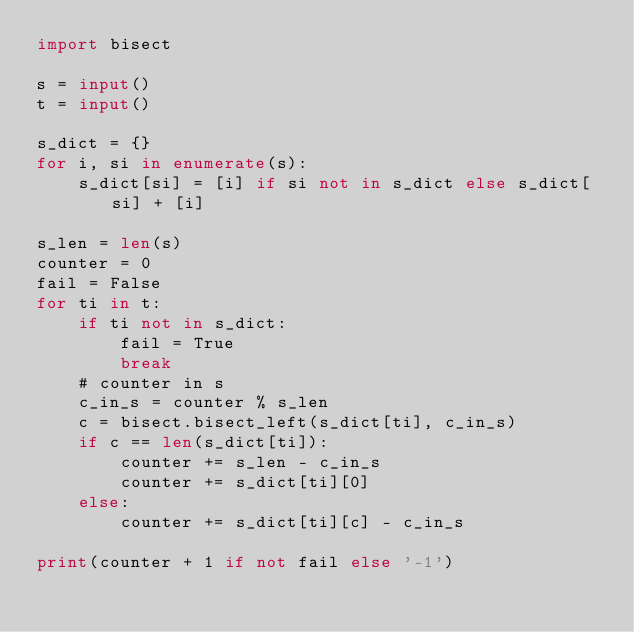Convert code to text. <code><loc_0><loc_0><loc_500><loc_500><_Python_>import bisect

s = input()
t = input()

s_dict = {}
for i, si in enumerate(s):
    s_dict[si] = [i] if si not in s_dict else s_dict[si] + [i]

s_len = len(s)
counter = 0
fail = False
for ti in t:
    if ti not in s_dict:
        fail = True
        break
    # counter in s
    c_in_s = counter % s_len
    c = bisect.bisect_left(s_dict[ti], c_in_s)
    if c == len(s_dict[ti]):
        counter += s_len - c_in_s
        counter += s_dict[ti][0]
    else:
        counter += s_dict[ti][c] - c_in_s

print(counter + 1 if not fail else '-1')
</code> 